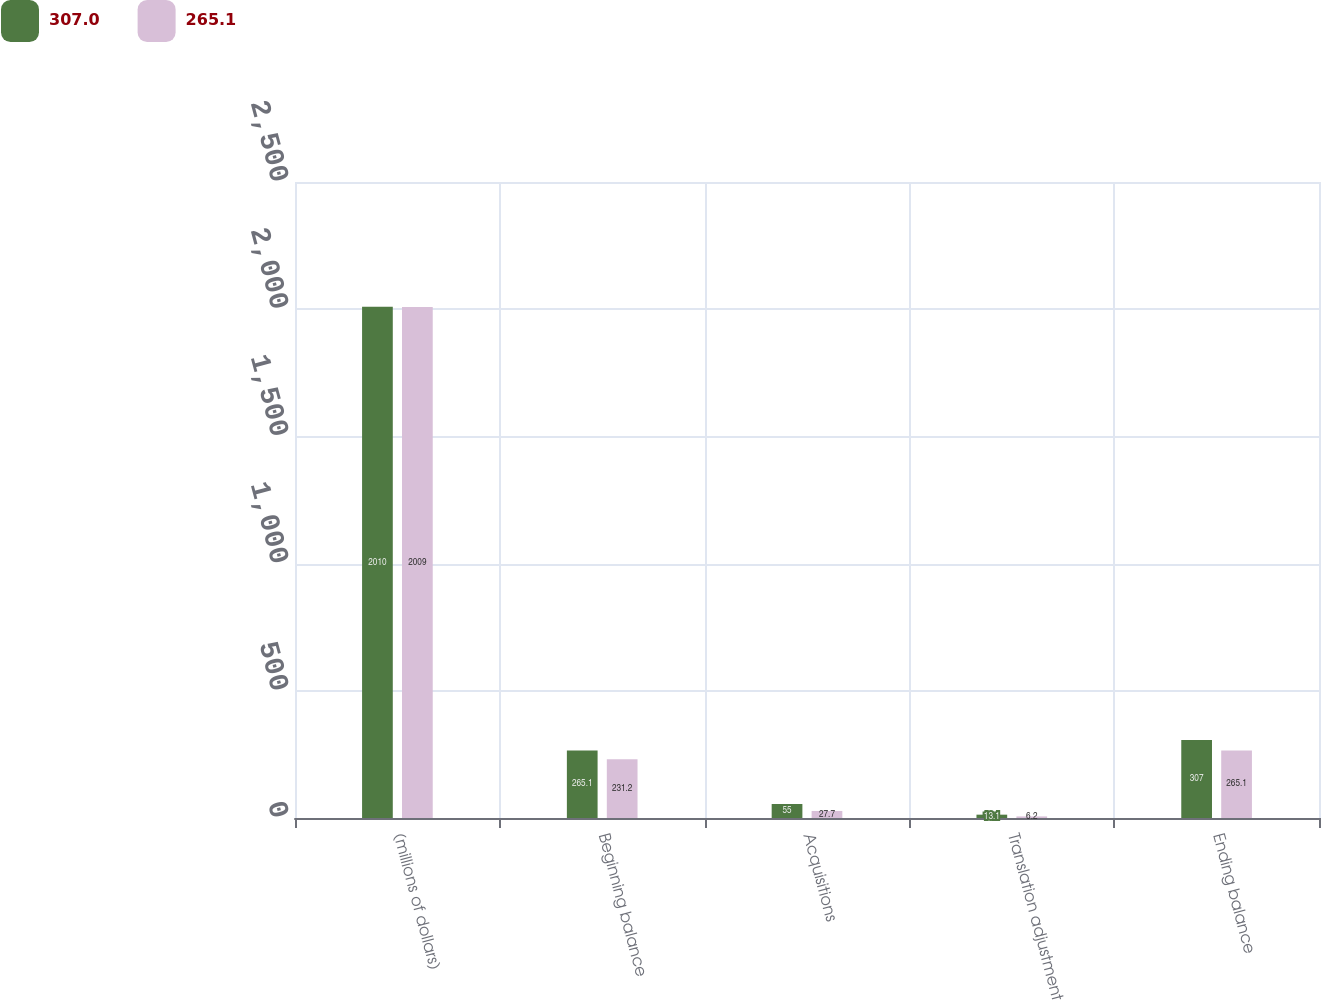Convert chart to OTSL. <chart><loc_0><loc_0><loc_500><loc_500><stacked_bar_chart><ecel><fcel>(millions of dollars)<fcel>Beginning balance<fcel>Acquisitions<fcel>Translation adjustment<fcel>Ending balance<nl><fcel>307<fcel>2010<fcel>265.1<fcel>55<fcel>13.1<fcel>307<nl><fcel>265.1<fcel>2009<fcel>231.2<fcel>27.7<fcel>6.2<fcel>265.1<nl></chart> 